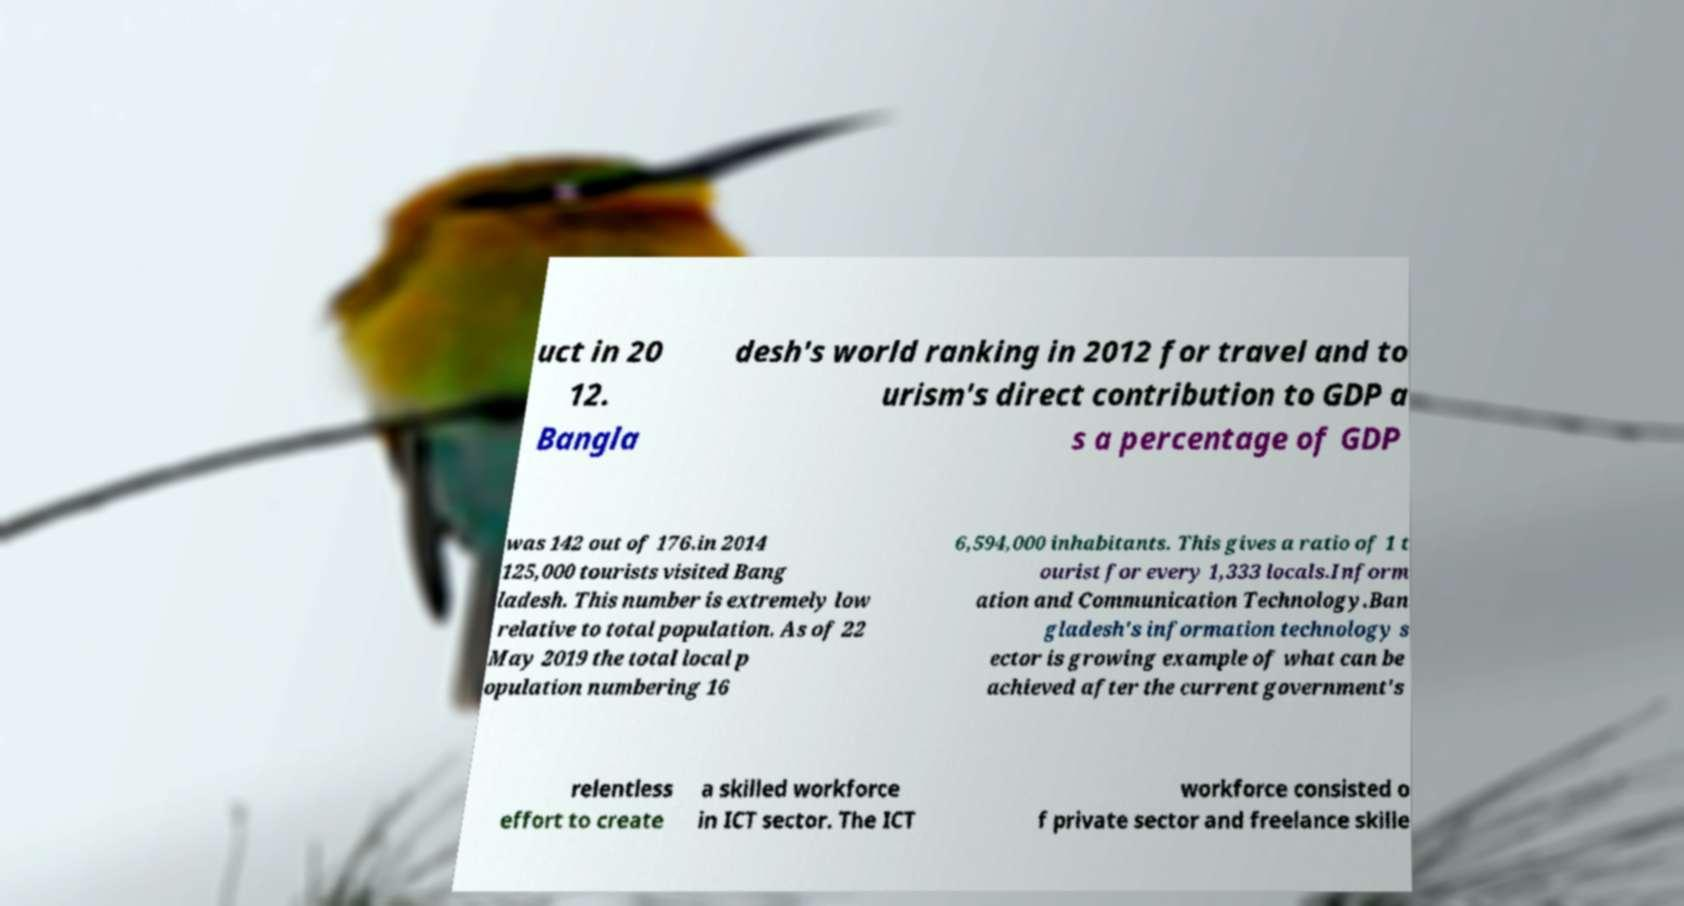For documentation purposes, I need the text within this image transcribed. Could you provide that? uct in 20 12. Bangla desh's world ranking in 2012 for travel and to urism's direct contribution to GDP a s a percentage of GDP was 142 out of 176.in 2014 125,000 tourists visited Bang ladesh. This number is extremely low relative to total population. As of 22 May 2019 the total local p opulation numbering 16 6,594,000 inhabitants. This gives a ratio of 1 t ourist for every 1,333 locals.Inform ation and Communication Technology.Ban gladesh's information technology s ector is growing example of what can be achieved after the current government's relentless effort to create a skilled workforce in ICT sector. The ICT workforce consisted o f private sector and freelance skille 